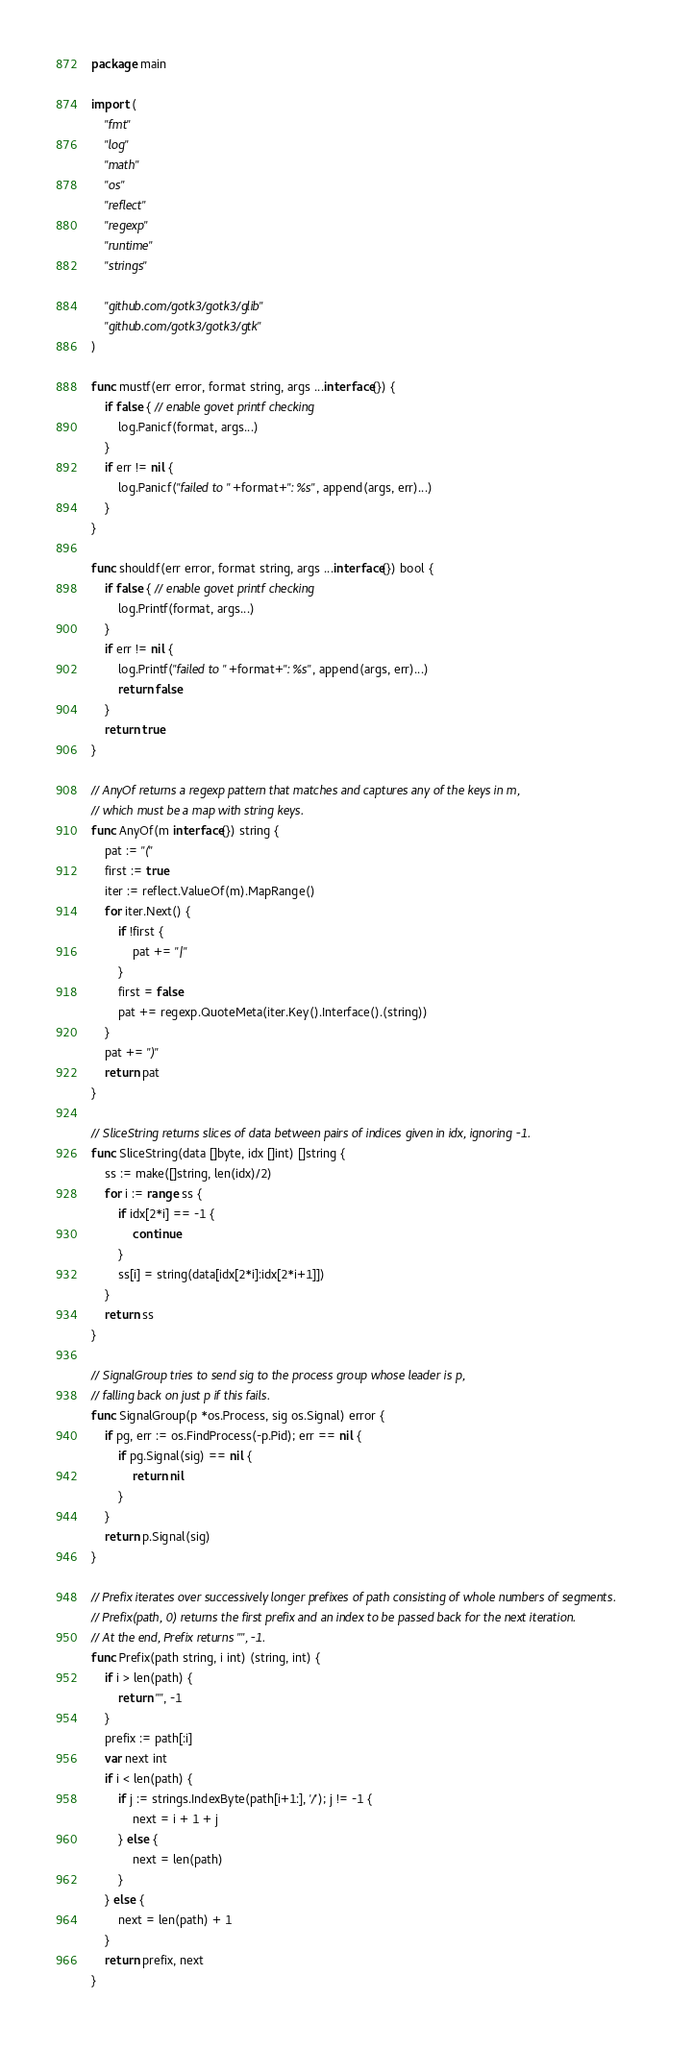<code> <loc_0><loc_0><loc_500><loc_500><_Go_>package main

import (
	"fmt"
	"log"
	"math"
	"os"
	"reflect"
	"regexp"
	"runtime"
	"strings"

	"github.com/gotk3/gotk3/glib"
	"github.com/gotk3/gotk3/gtk"
)

func mustf(err error, format string, args ...interface{}) {
	if false { // enable govet printf checking
		log.Panicf(format, args...)
	}
	if err != nil {
		log.Panicf("failed to "+format+": %s", append(args, err)...)
	}
}

func shouldf(err error, format string, args ...interface{}) bool {
	if false { // enable govet printf checking
		log.Printf(format, args...)
	}
	if err != nil {
		log.Printf("failed to "+format+": %s", append(args, err)...)
		return false
	}
	return true
}

// AnyOf returns a regexp pattern that matches and captures any of the keys in m,
// which must be a map with string keys.
func AnyOf(m interface{}) string {
	pat := "("
	first := true
	iter := reflect.ValueOf(m).MapRange()
	for iter.Next() {
		if !first {
			pat += "|"
		}
		first = false
		pat += regexp.QuoteMeta(iter.Key().Interface().(string))
	}
	pat += ")"
	return pat
}

// SliceString returns slices of data between pairs of indices given in idx, ignoring -1.
func SliceString(data []byte, idx []int) []string {
	ss := make([]string, len(idx)/2)
	for i := range ss {
		if idx[2*i] == -1 {
			continue
		}
		ss[i] = string(data[idx[2*i]:idx[2*i+1]])
	}
	return ss
}

// SignalGroup tries to send sig to the process group whose leader is p,
// falling back on just p if this fails.
func SignalGroup(p *os.Process, sig os.Signal) error {
	if pg, err := os.FindProcess(-p.Pid); err == nil {
		if pg.Signal(sig) == nil {
			return nil
		}
	}
	return p.Signal(sig)
}

// Prefix iterates over successively longer prefixes of path consisting of whole numbers of segments.
// Prefix(path, 0) returns the first prefix and an index to be passed back for the next iteration.
// At the end, Prefix returns "", -1.
func Prefix(path string, i int) (string, int) {
	if i > len(path) {
		return "", -1
	}
	prefix := path[:i]
	var next int
	if i < len(path) {
		if j := strings.IndexByte(path[i+1:], '/'); j != -1 {
			next = i + 1 + j
		} else {
			next = len(path)
		}
	} else {
		next = len(path) + 1
	}
	return prefix, next
}
</code> 